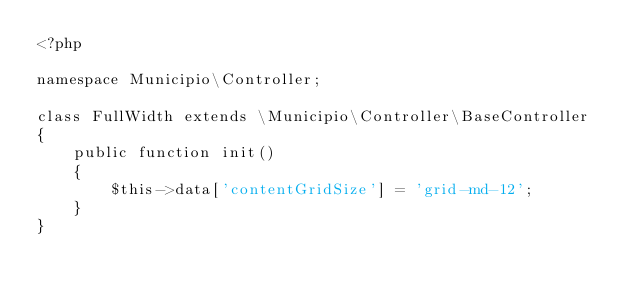<code> <loc_0><loc_0><loc_500><loc_500><_PHP_><?php

namespace Municipio\Controller;

class FullWidth extends \Municipio\Controller\BaseController
{
    public function init()
    {
        $this->data['contentGridSize'] = 'grid-md-12';
    }
}
</code> 